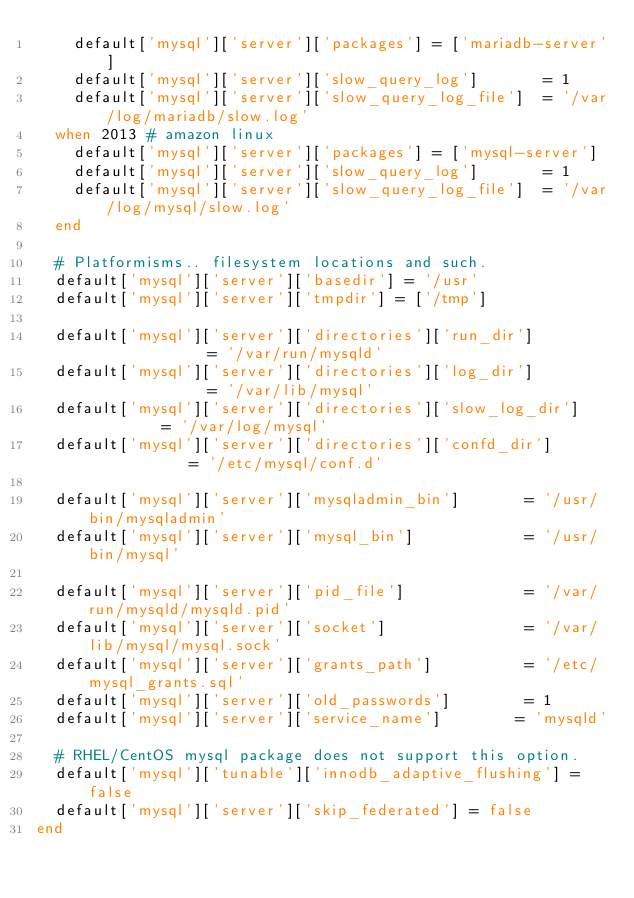<code> <loc_0><loc_0><loc_500><loc_500><_Ruby_>    default['mysql']['server']['packages'] = ['mariadb-server']
    default['mysql']['server']['slow_query_log']       = 1
    default['mysql']['server']['slow_query_log_file']  = '/var/log/mariadb/slow.log'
  when 2013 # amazon linux
    default['mysql']['server']['packages'] = ['mysql-server']
    default['mysql']['server']['slow_query_log']       = 1
    default['mysql']['server']['slow_query_log_file']  = '/var/log/mysql/slow.log'
  end

  # Platformisms.. filesystem locations and such.
  default['mysql']['server']['basedir'] = '/usr'
  default['mysql']['server']['tmpdir'] = ['/tmp']

  default['mysql']['server']['directories']['run_dir']              = '/var/run/mysqld'
  default['mysql']['server']['directories']['log_dir']              = '/var/lib/mysql'
  default['mysql']['server']['directories']['slow_log_dir']         = '/var/log/mysql'
  default['mysql']['server']['directories']['confd_dir']            = '/etc/mysql/conf.d'

  default['mysql']['server']['mysqladmin_bin']       = '/usr/bin/mysqladmin'
  default['mysql']['server']['mysql_bin']            = '/usr/bin/mysql'

  default['mysql']['server']['pid_file']             = '/var/run/mysqld/mysqld.pid'
  default['mysql']['server']['socket']               = '/var/lib/mysql/mysql.sock'
  default['mysql']['server']['grants_path']          = '/etc/mysql_grants.sql'
  default['mysql']['server']['old_passwords']        = 1
  default['mysql']['server']['service_name']        = 'mysqld'

  # RHEL/CentOS mysql package does not support this option.
  default['mysql']['tunable']['innodb_adaptive_flushing'] = false
  default['mysql']['server']['skip_federated'] = false
end
</code> 